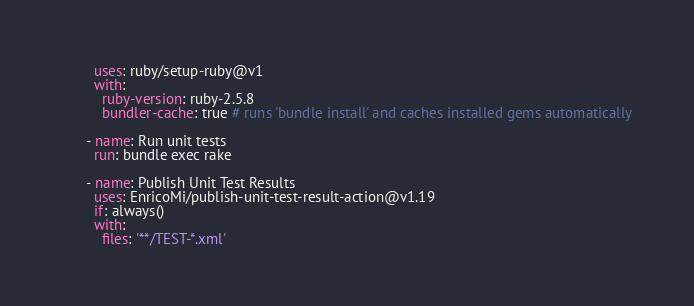<code> <loc_0><loc_0><loc_500><loc_500><_YAML_>        uses: ruby/setup-ruby@v1
        with:
          ruby-version: ruby-2.5.8
          bundler-cache: true # runs 'bundle install' and caches installed gems automatically

      - name: Run unit tests
        run: bundle exec rake

      - name: Publish Unit Test Results
        uses: EnricoMi/publish-unit-test-result-action@v1.19
        if: always()
        with:
          files: '**/TEST-*.xml'
</code> 